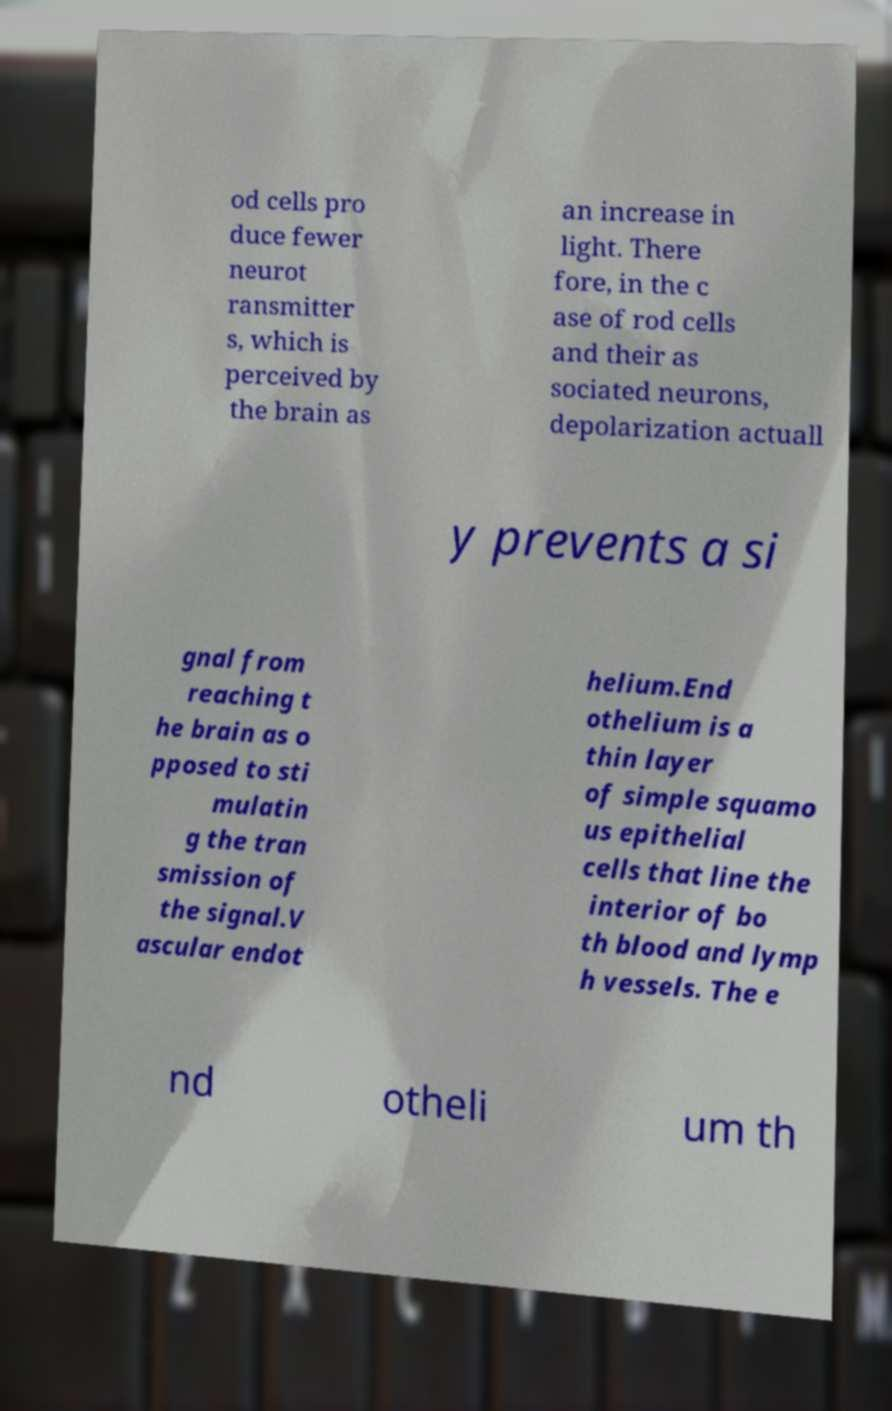Could you assist in decoding the text presented in this image and type it out clearly? od cells pro duce fewer neurot ransmitter s, which is perceived by the brain as an increase in light. There fore, in the c ase of rod cells and their as sociated neurons, depolarization actuall y prevents a si gnal from reaching t he brain as o pposed to sti mulatin g the tran smission of the signal.V ascular endot helium.End othelium is a thin layer of simple squamo us epithelial cells that line the interior of bo th blood and lymp h vessels. The e nd otheli um th 